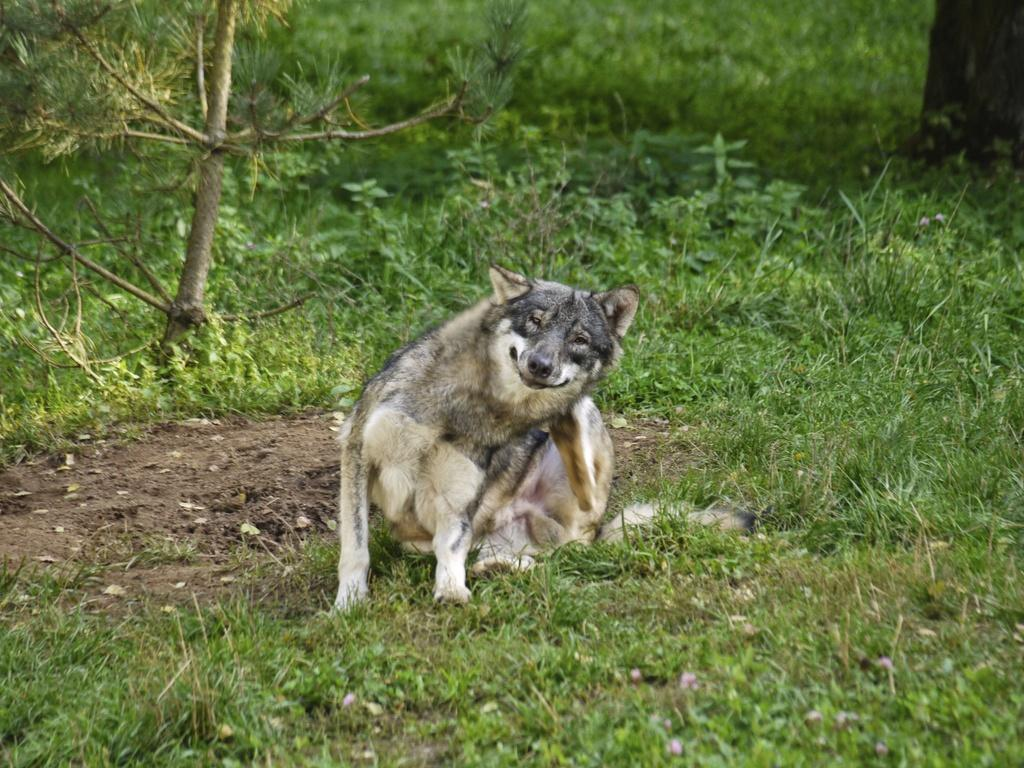What type of animal is present in the image? There is a dog in the image. What is the dog doing in the image? The dog is sitting in a field. What can be seen in the background of the image? There are trees in the background of the image. What type of curtain can be seen hanging in the field where the dog is sitting? There is no curtain present in the image; it is a field with a dog sitting in it and trees in the background. 